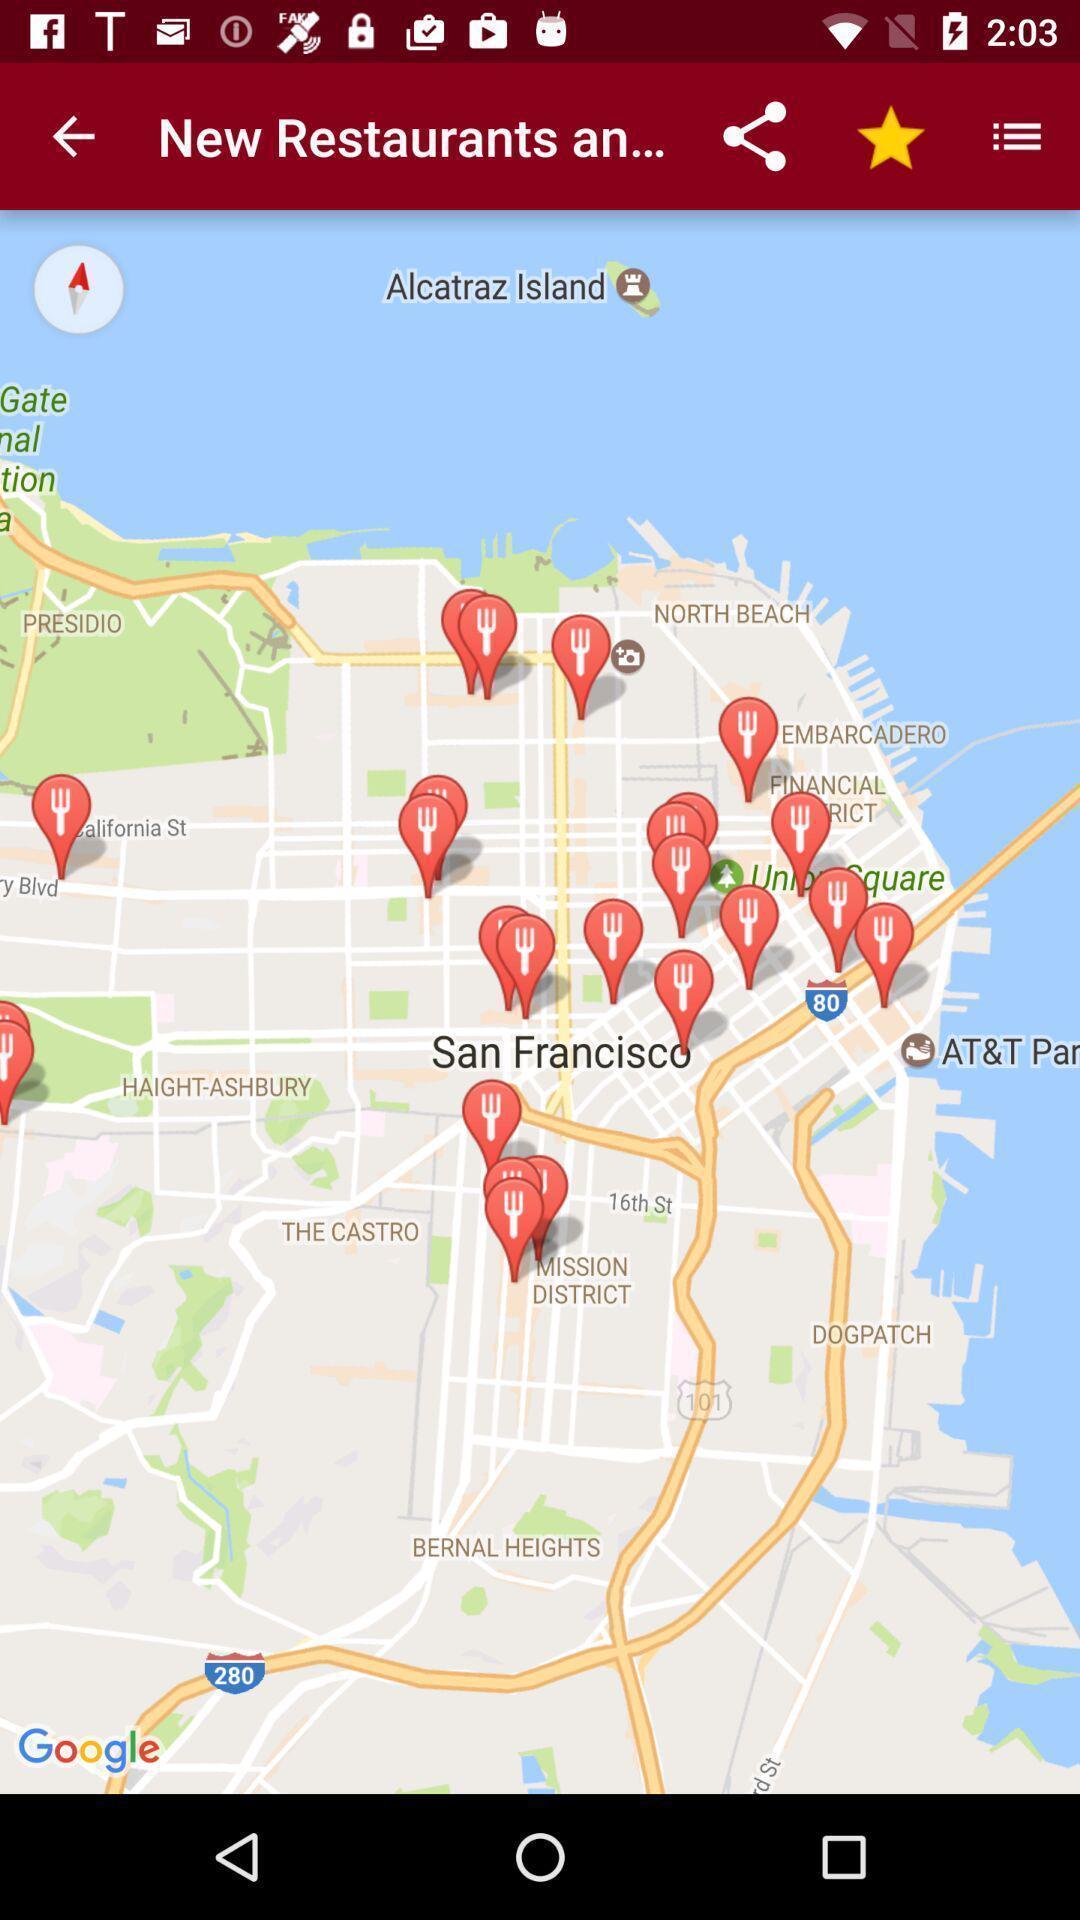Provide a textual representation of this image. Screen page displaying map with different options. 